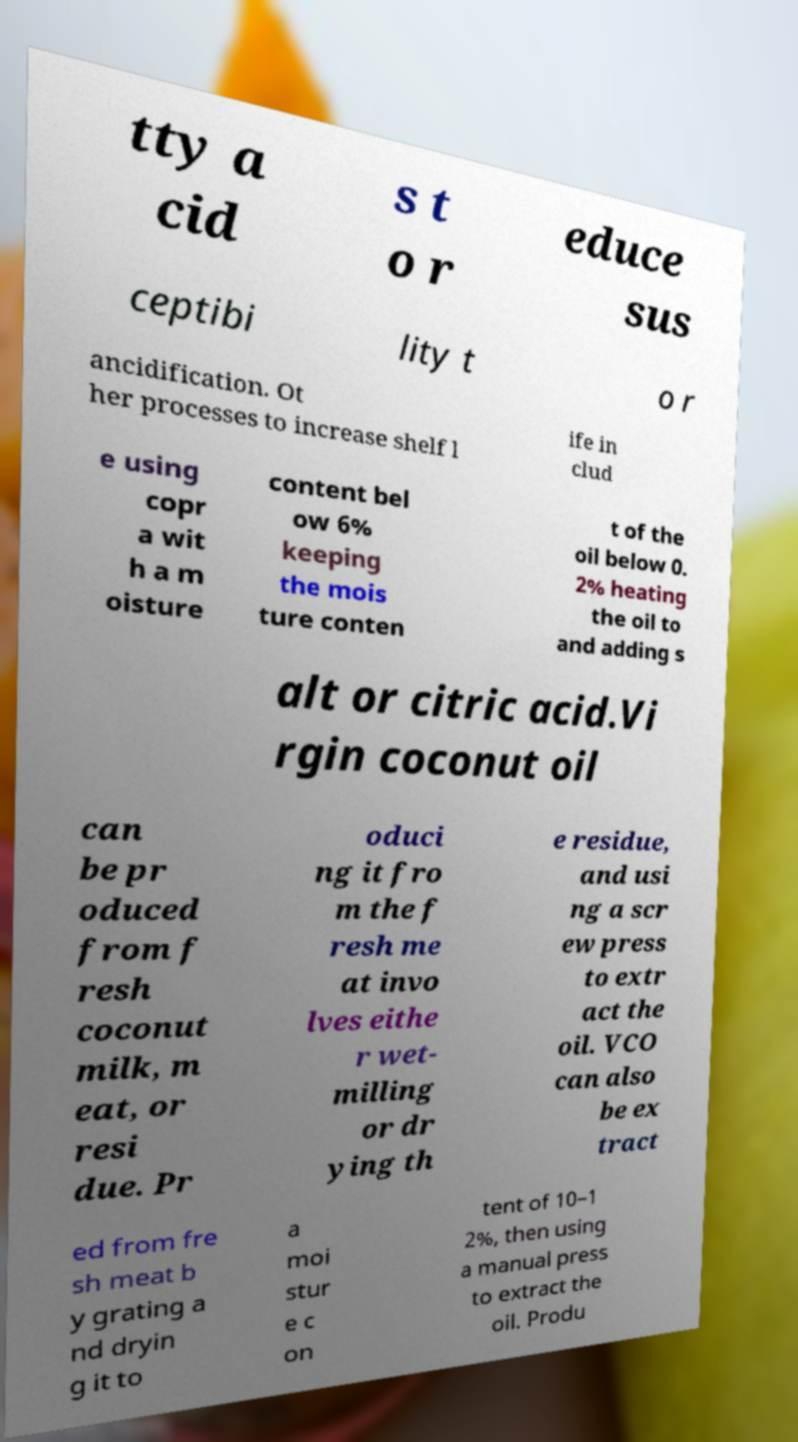Can you accurately transcribe the text from the provided image for me? tty a cid s t o r educe sus ceptibi lity t o r ancidification. Ot her processes to increase shelf l ife in clud e using copr a wit h a m oisture content bel ow 6% keeping the mois ture conten t of the oil below 0. 2% heating the oil to and adding s alt or citric acid.Vi rgin coconut oil can be pr oduced from f resh coconut milk, m eat, or resi due. Pr oduci ng it fro m the f resh me at invo lves eithe r wet- milling or dr ying th e residue, and usi ng a scr ew press to extr act the oil. VCO can also be ex tract ed from fre sh meat b y grating a nd dryin g it to a moi stur e c on tent of 10–1 2%, then using a manual press to extract the oil. Produ 